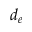Convert formula to latex. <formula><loc_0><loc_0><loc_500><loc_500>d _ { e }</formula> 